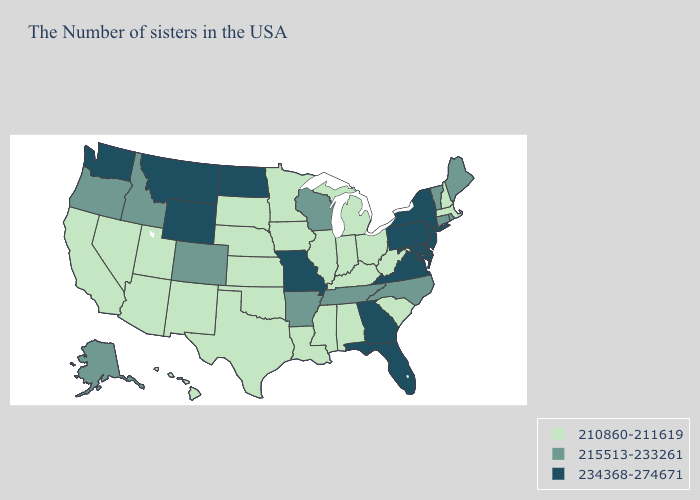Which states have the lowest value in the West?
Write a very short answer. New Mexico, Utah, Arizona, Nevada, California, Hawaii. What is the highest value in states that border Louisiana?
Short answer required. 215513-233261. What is the highest value in states that border Vermont?
Be succinct. 234368-274671. Does New Mexico have a higher value than Nevada?
Write a very short answer. No. What is the value of Kansas?
Keep it brief. 210860-211619. Name the states that have a value in the range 210860-211619?
Quick response, please. Massachusetts, New Hampshire, South Carolina, West Virginia, Ohio, Michigan, Kentucky, Indiana, Alabama, Illinois, Mississippi, Louisiana, Minnesota, Iowa, Kansas, Nebraska, Oklahoma, Texas, South Dakota, New Mexico, Utah, Arizona, Nevada, California, Hawaii. Among the states that border Washington , which have the lowest value?
Concise answer only. Idaho, Oregon. Does Pennsylvania have the same value as Iowa?
Answer briefly. No. Does Idaho have the same value as Arizona?
Answer briefly. No. How many symbols are there in the legend?
Write a very short answer. 3. What is the value of Hawaii?
Answer briefly. 210860-211619. Does Alaska have the lowest value in the West?
Keep it brief. No. What is the value of Oregon?
Give a very brief answer. 215513-233261. Name the states that have a value in the range 234368-274671?
Short answer required. New York, New Jersey, Delaware, Maryland, Pennsylvania, Virginia, Florida, Georgia, Missouri, North Dakota, Wyoming, Montana, Washington. 